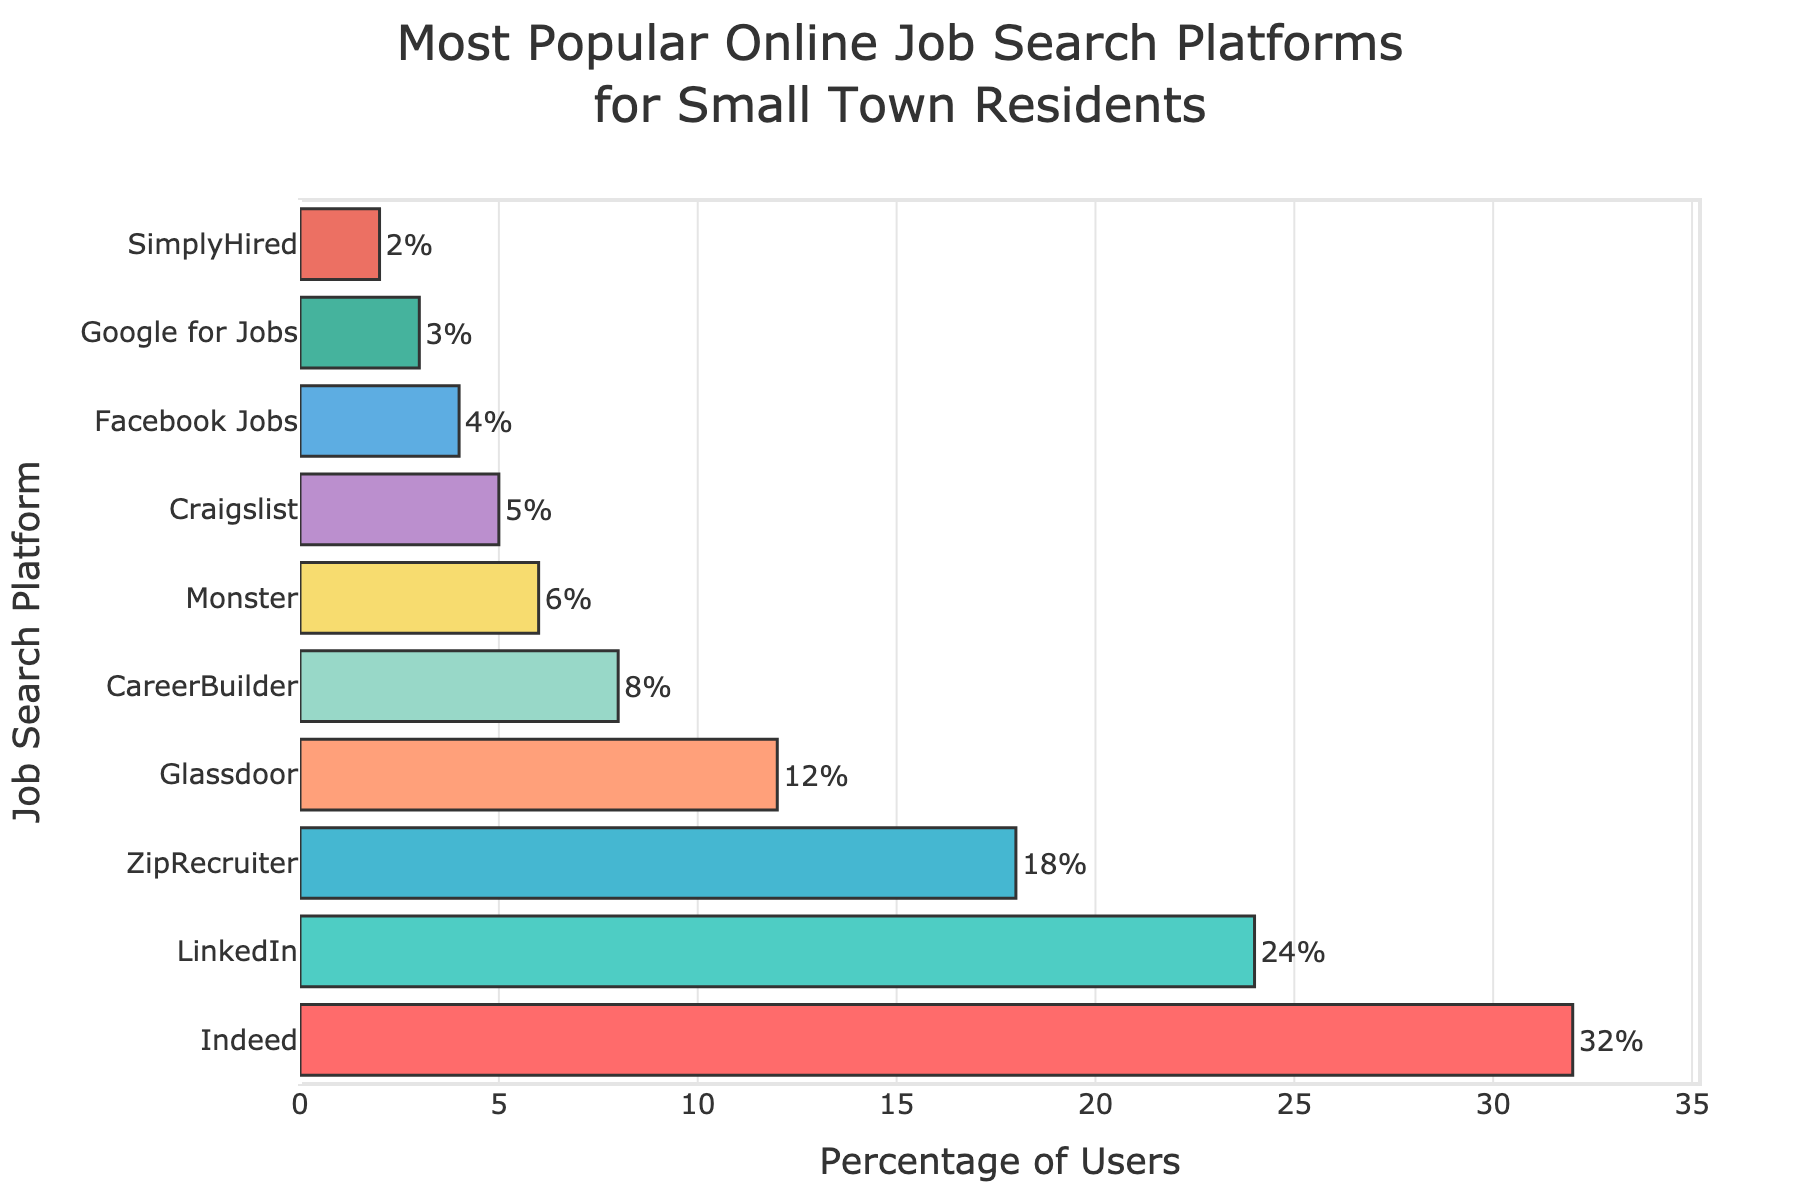Which job search platform is the most popular among small town residents? The bar chart shows that the platform with the highest percentage value is Indeed.
Answer: Indeed Which two job search platforms have a combined percentage equal to LinkedIn's percentage? LinkedIn has a percentage of 24%. CareerBuilder (8%) and Glassdoor (12%) together sum up to 20%, while no other combination exactly equals 24%. This suggests the question is a bit tricky as there is no exact match among the data provided to equal LinkedIn's percentage. Instead, combinations like ZipRecruiter (18%) and Monster (6%) sum up closely to LinkedIn's percentage.
Answer: There is no exact match, but ZipRecruiter and Monster sum up to 24% Which platform has the lowest usage percentage? By looking at the smallest bar, we see that SimplyHired has the lowest percentage with 2%.
Answer: SimplyHired How much higher is the percentage of users for Indeed compared to Monster? Indeed has 32% and Monster has 6%. The difference is 32% - 6% = 26%.
Answer: 26% Which platform has a slightly higher usage percentage than Craigslist? Craigslist has 5%, and Facebook Jobs, which follows, has 4%, indicating Craigslist is higher. Therefore, it turns out that Monster with 6% is slightly higher than Craigslist.
Answer: Monster Among the platforms, which one is represented by the longest bar? The longest bar corresponds to the platform with the highest percentage, which is Indeed.
Answer: Indeed How much greater is the combined percentage of LinkedIn and Glassdoor compared to ZipRecruiter? LinkedIn and Glassdoor together have 24% + 12% = 36%. ZipRecruiter has 18%. The difference is 36% - 18% = 18%.
Answer: 18% What is the combined percentage usage of Google for Jobs and SimplyHired? Google for Jobs has 3% and SimplyHired has 2%. Their combined percentage is 3% + 2% = 5%.
Answer: 5% How many platforms have a higher usage percentage than CareerBuilder? CareerBuilder has 8%. Platforms with higher percentages are Indeed (32%), LinkedIn (24%), ZipRecruiter (18%), and Glassdoor (12%)—a total of 4 platforms.
Answer: 4 